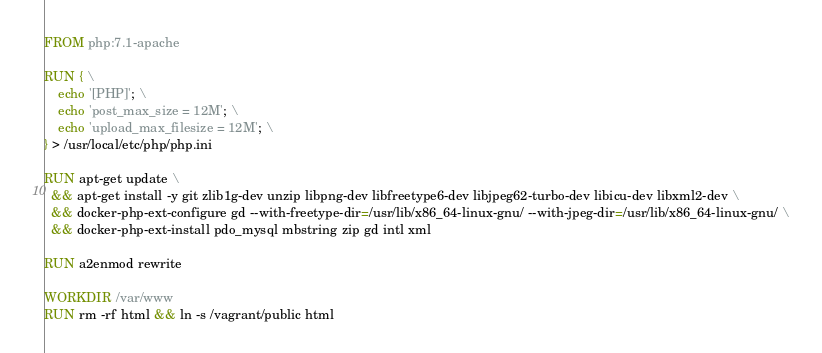Convert code to text. <code><loc_0><loc_0><loc_500><loc_500><_Dockerfile_>FROM php:7.1-apache

RUN { \
    echo '[PHP]'; \
    echo 'post_max_size = 12M'; \
    echo 'upload_max_filesize = 12M'; \
} > /usr/local/etc/php/php.ini

RUN apt-get update \
  && apt-get install -y git zlib1g-dev unzip libpng-dev libfreetype6-dev libjpeg62-turbo-dev libicu-dev libxml2-dev \
  && docker-php-ext-configure gd --with-freetype-dir=/usr/lib/x86_64-linux-gnu/ --with-jpeg-dir=/usr/lib/x86_64-linux-gnu/ \
  && docker-php-ext-install pdo_mysql mbstring zip gd intl xml

RUN a2enmod rewrite

WORKDIR /var/www
RUN rm -rf html && ln -s /vagrant/public html
</code> 